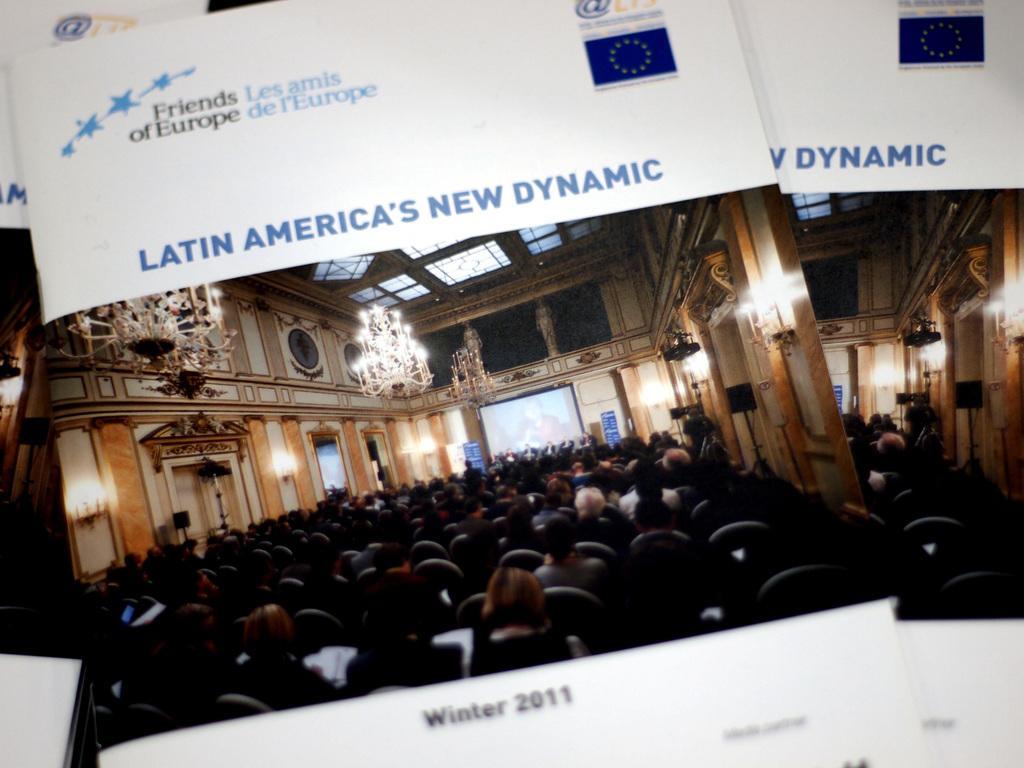Could you give a brief overview of what you see in this image? In this image there are books having some text and a photo. There are people sitting on the chairs. Few people are on the stage having boards. There is a screen attached to the wall. There are chandeliers hanging from the roof. Top of the image there is some text. 